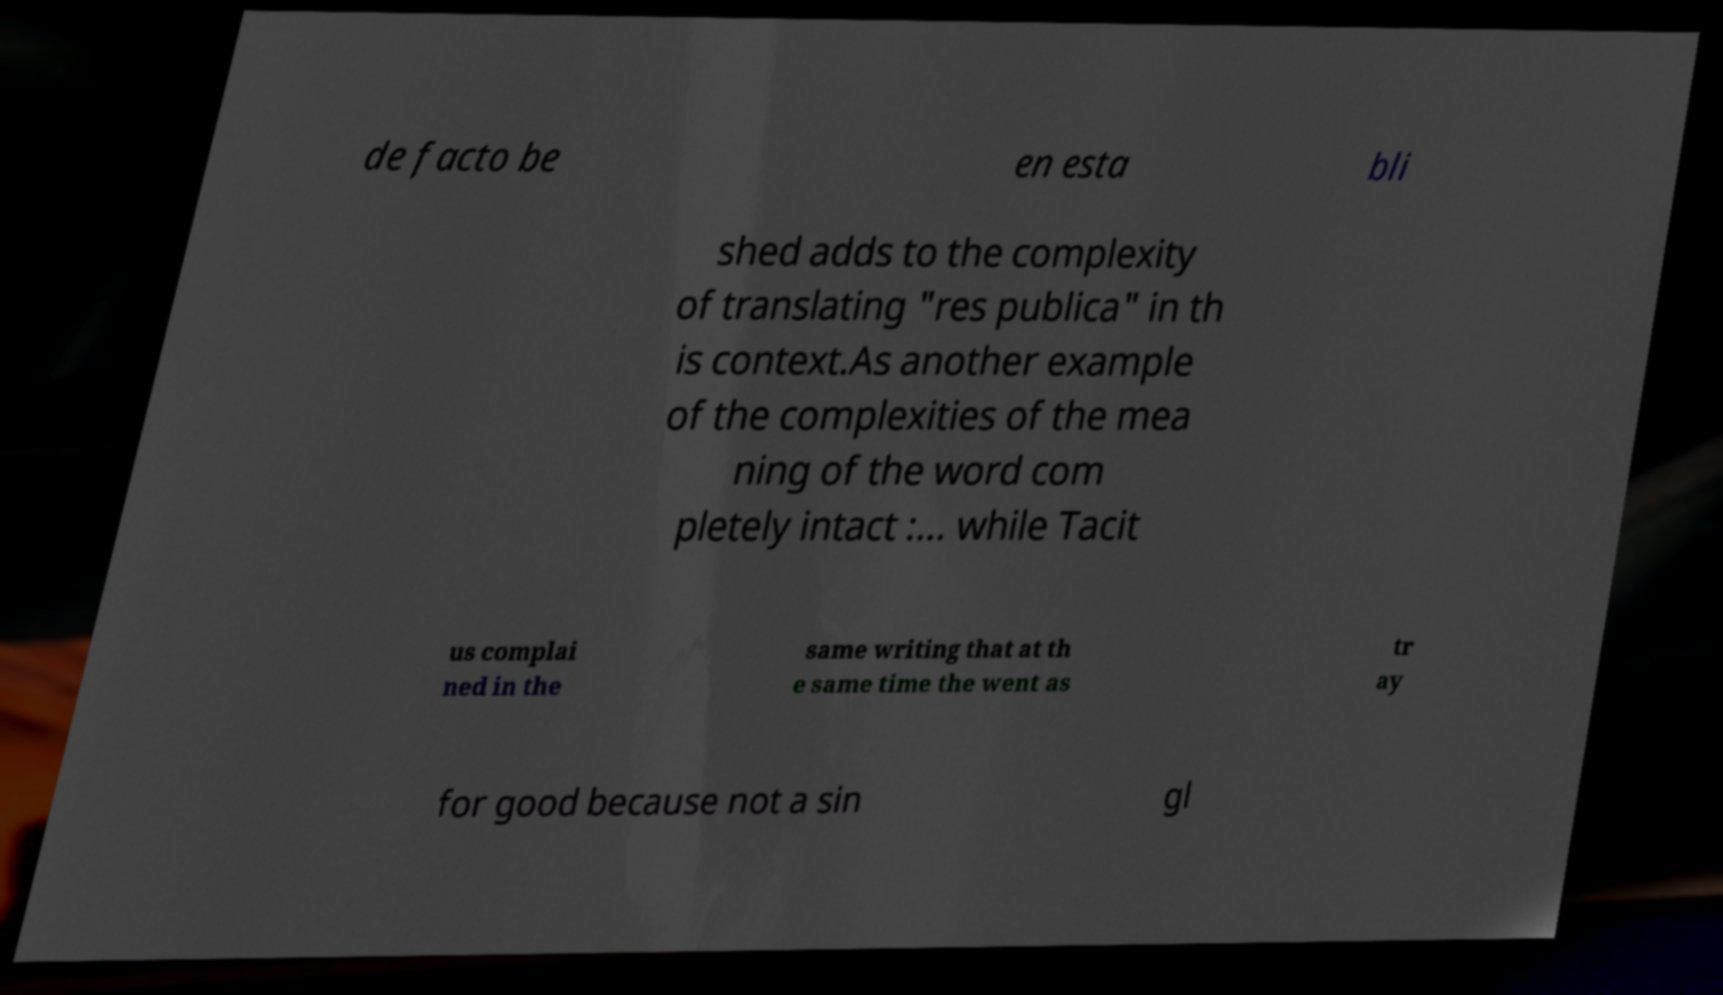Please read and relay the text visible in this image. What does it say? de facto be en esta bli shed adds to the complexity of translating "res publica" in th is context.As another example of the complexities of the mea ning of the word com pletely intact :... while Tacit us complai ned in the same writing that at th e same time the went as tr ay for good because not a sin gl 